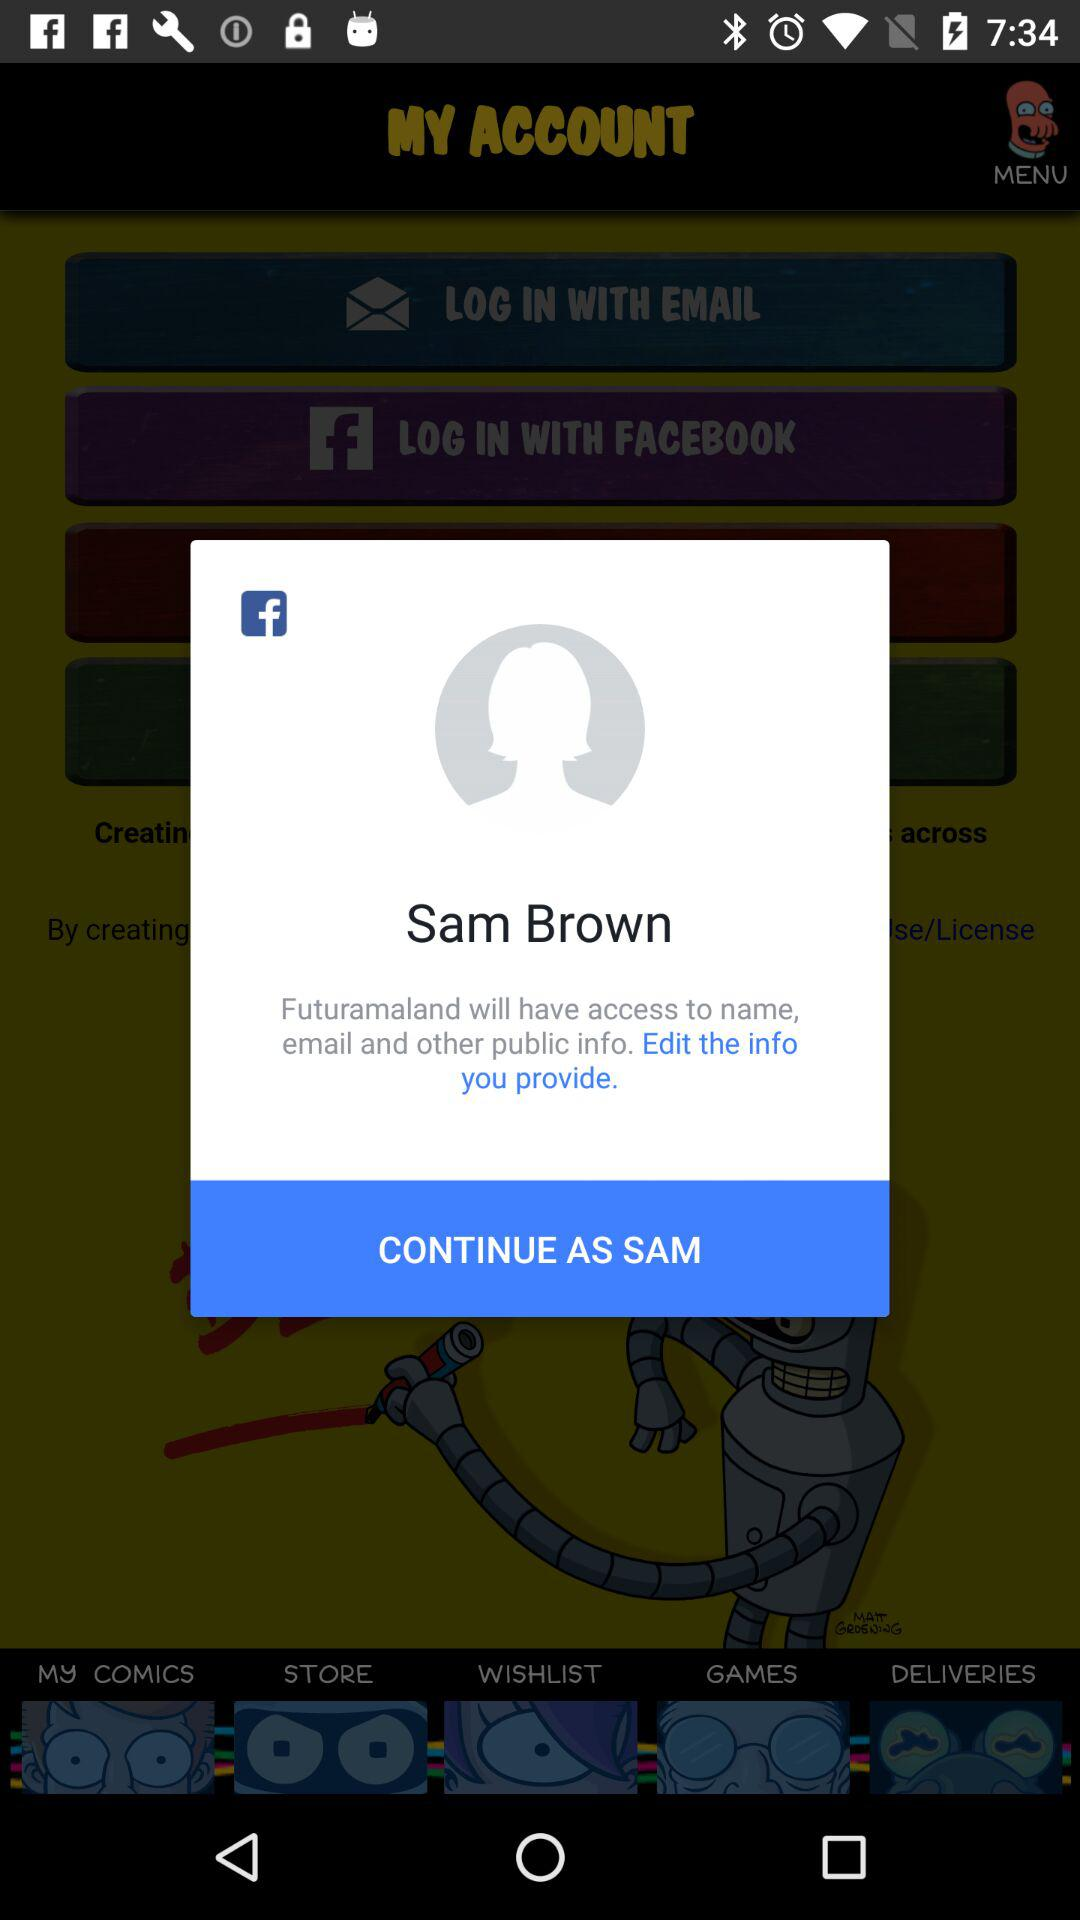What is the user name? The user name is Sam Brown. 